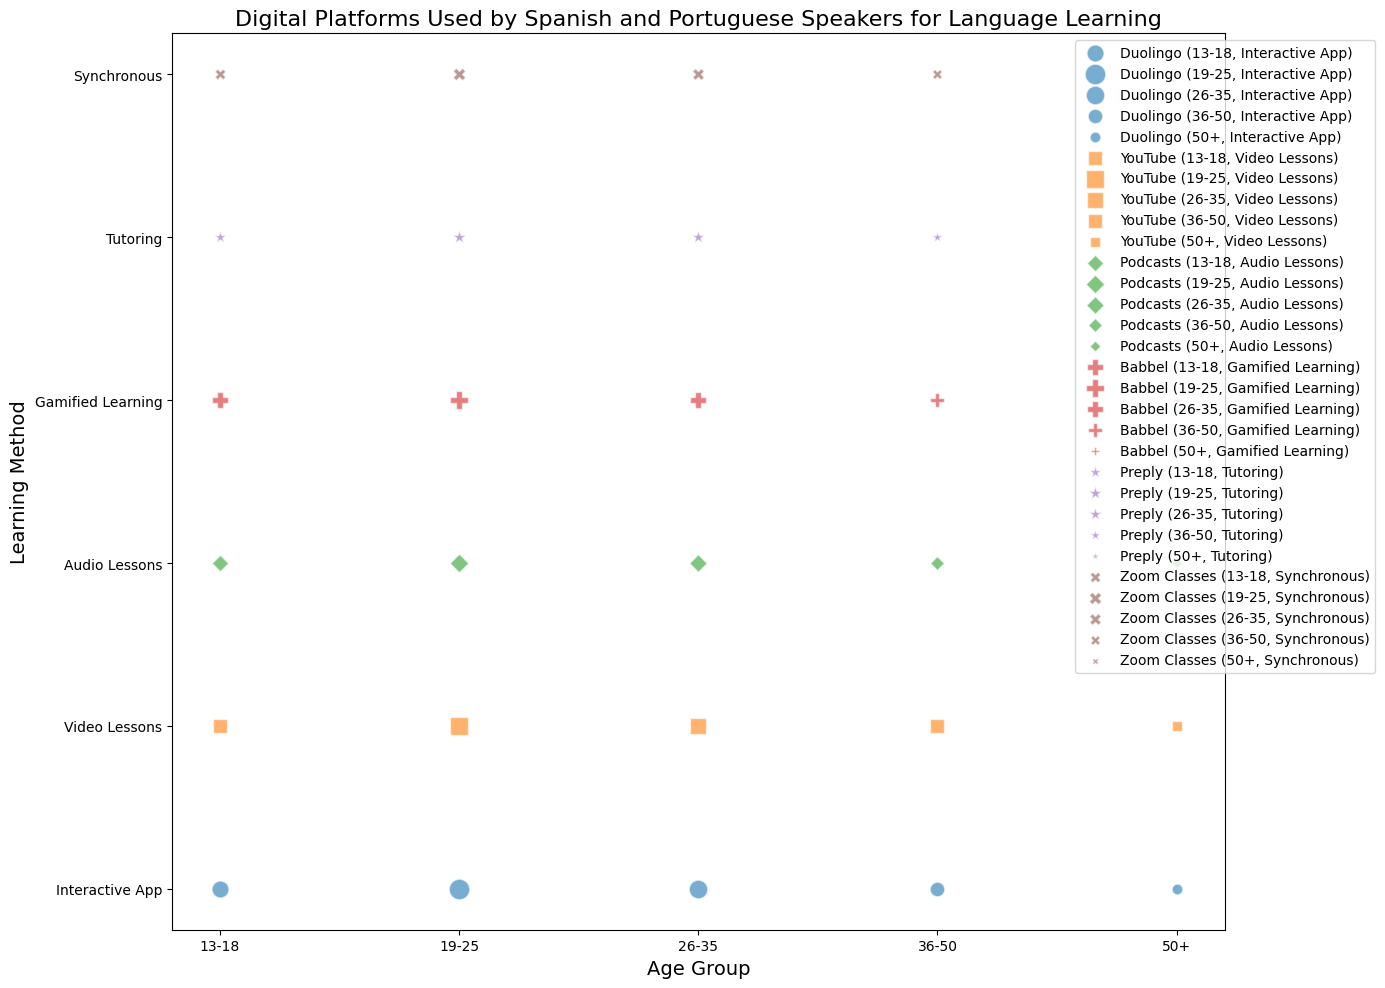Which age group uses Duolingo most frequently? From the scatterplot, look at the age group along the x-axis for the platform marker with the largest size, specifically for Duolingo. The 19-25 age group has the largest bubble representing Duolingo, indicating they have the most users.
Answer: 19-25 Which learning method is most preferred among users aged 50+? Observe the y-axis (learning methods) for the column corresponding to the 50+ age group to see which method has the largest marker size. Interactive App has the largest marker, indicating it is the most preferred method for this age group.
Answer: Interactive App What is the difference in users between the 13-18 and 36-50 age group using Babbel for Gamified Learning? Look at the bubble sizes for both age groups under the "Gamified Learning" method for the Babbel platform. The 13-18 age group has 1200 users while the 36-50 age group has 900 users. The difference is 1200 - 900.
Answer: 300 Comparing YouTube and Podcasts, which platform has more users for Video Lessons among users aged 26-35? Locate the bubbles for YouTube and Podcasts under the "Video Lessons" method in the 26-35 age column. The bubble for YouTube is significantly larger than that for Podcasts.
Answer: YouTube What is the combined number of users for Synchronous learning methods across all age groups? Add up the sizes of all bubbles for the Synchronous learning method across all age groups (13-18: 600, 19-25: 800, 26-35: 700, 36-50: 500, 50+: 200). Total is 600 + 800 + 700 + 500 + 200.
Answer: 2800 Which platform has the smallest user base among the 50+ age group? Look at the age group 50+ and compare all the bubble sizes. The smallest bubble corresponds to the Synchronous method on the Zoom Classes platform.
Answer: Zoom Classes For the 19-25 age group, how does the user count of those using Interactive Apps compare to those using Video Lessons? Locate the bubbles for "Interactive App" and "Video Lessons" in the 19-25 age group. The Interactive App (Duolingo) has 2200 users and Video Lessons (YouTube) has 1700. Interactive App has more users.
Answer: Interactive App has more users What is the ratio of users using Interactive Apps to those using Audio Lessons in the 26-35 age group? Locate the user counts for Interactive Apps (Duolingo) and Audio Lessons (Podcasts) in the 26-35 age group. Interactive App has 1800 users and Audio Lessons have 800. The ratio is 1800:800, which simplifies to 9:4.
Answer: 9:4 